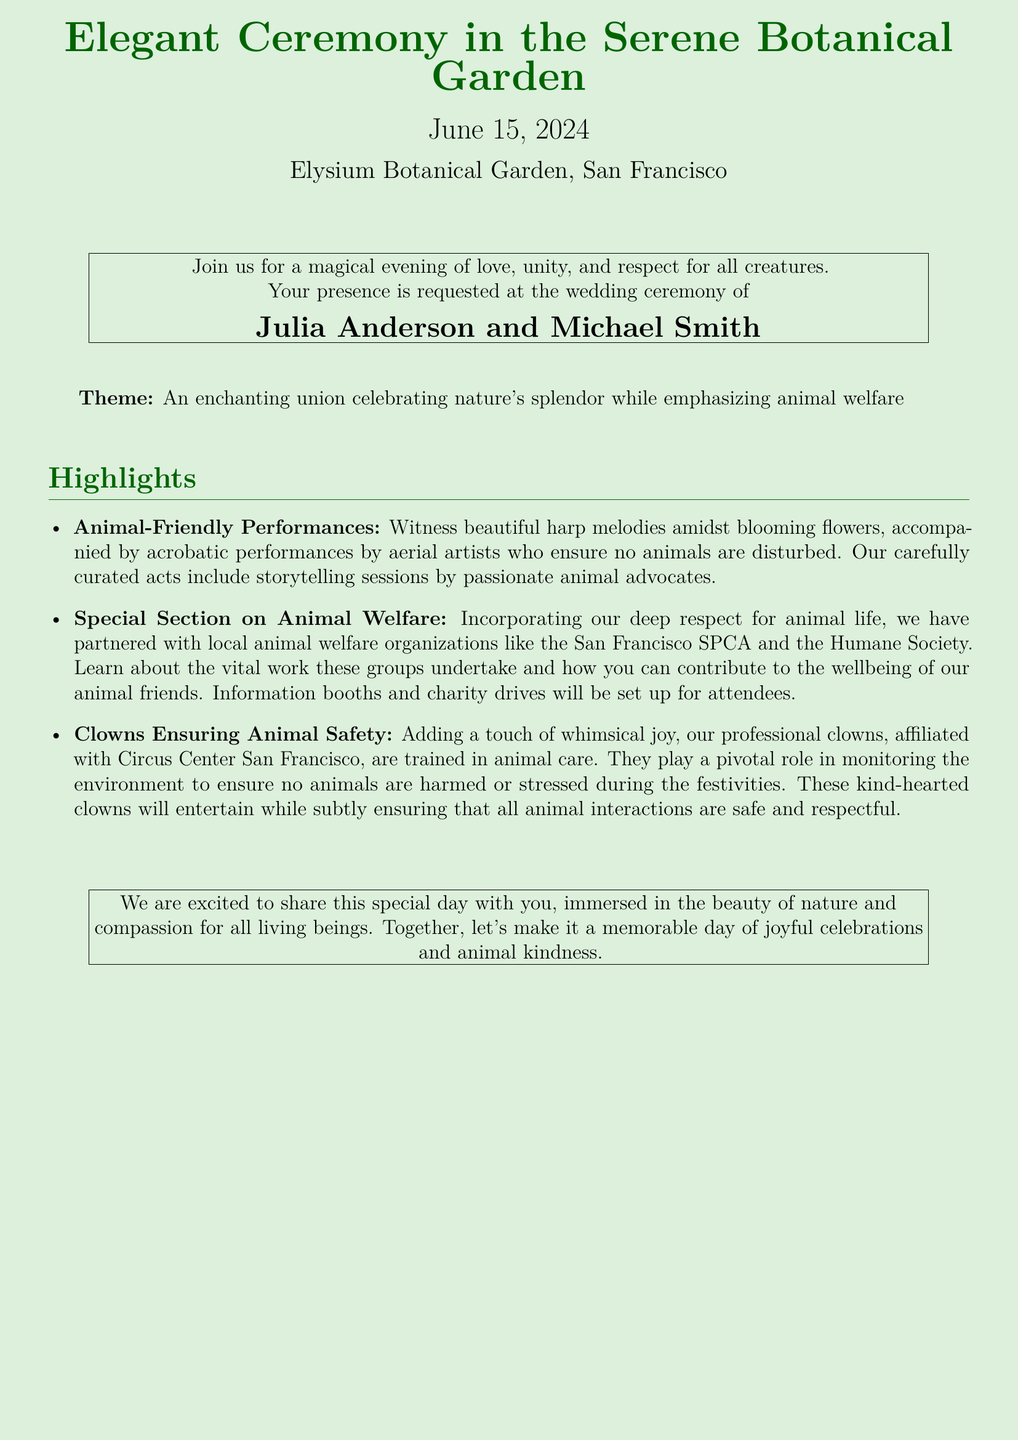What is the wedding date? The specific date of the wedding is mentioned clearly in the document.
Answer: June 15, 2024 Where is the ceremony taking place? The location of the ceremony is stated in the invitation.
Answer: Elysium Botanical Garden, San Francisco Who are the couple getting married? The document highlights the names of the individuals who are getting married.
Answer: Julia Anderson and Michael Smith What type of performances are included in the ceremony? The document mentions specific activities that will occur during the event.
Answer: Animal-Friendly Performances Which organizations are mentioned for animal welfare? The document lists local organizations that are emphasized for their animal welfare work.
Answer: San Francisco SPCA and the Humane Society What role do the clowns play at the ceremony? The document describes the function of the clowns in relation to animal safety.
Answer: Ensuring animal safety What is emphasized alongside nature during the celebration? The document indicates a key theme that accompanies the wedding's natural setting.
Answer: Animal welfare What can attendees engage with at the event? The invitation describes specific interactive opportunities available during the ceremony.
Answer: Information booths and charity drives 